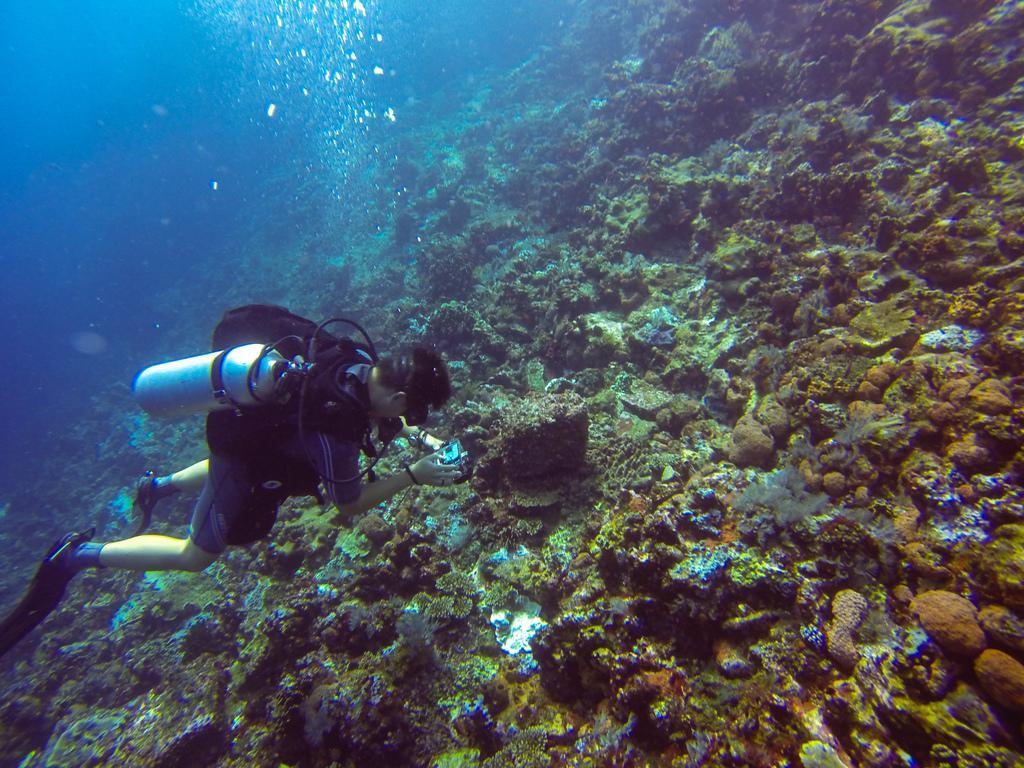Please provide a concise description of this image. In the center of the image there is a person under the water and cylinder on his back. In the background we can see stones. 